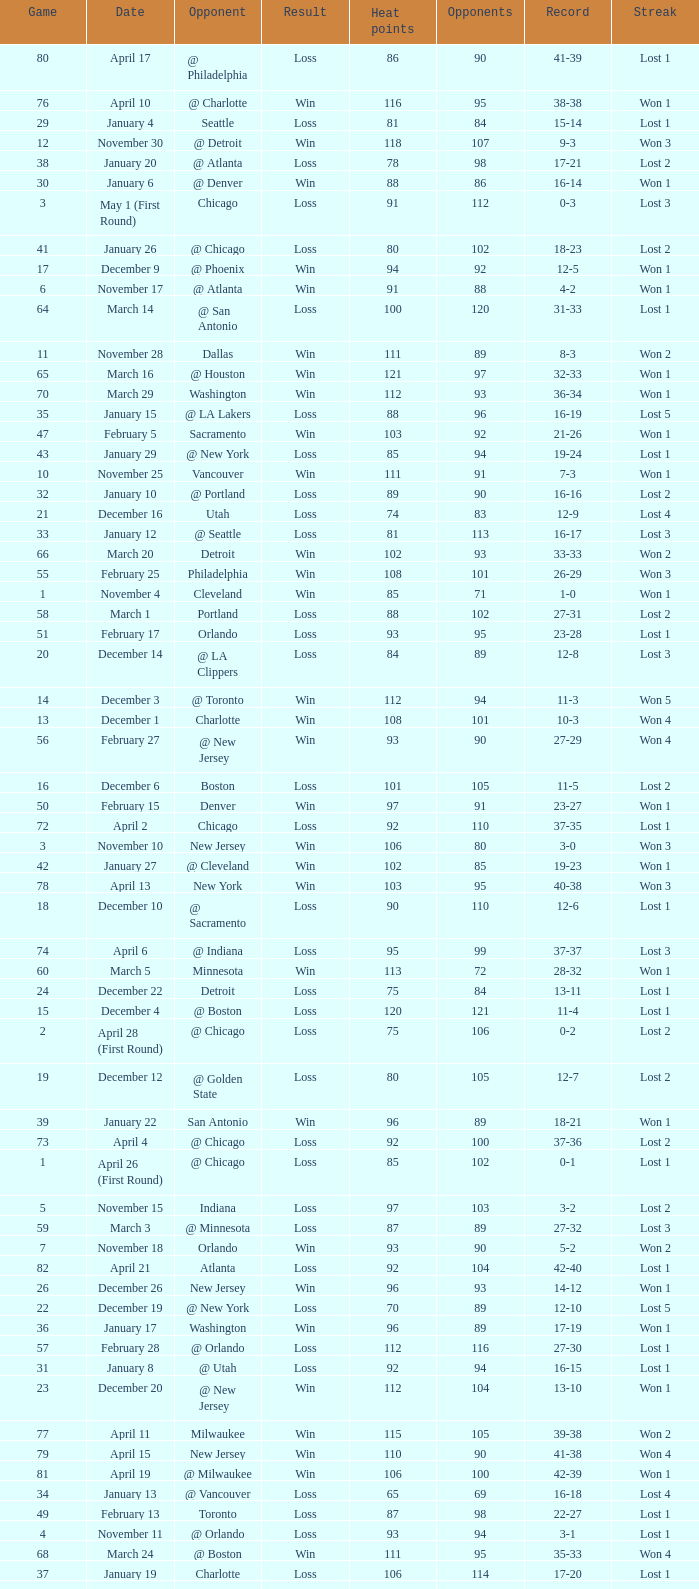What is Result, when Date is "December 12"? Loss. 